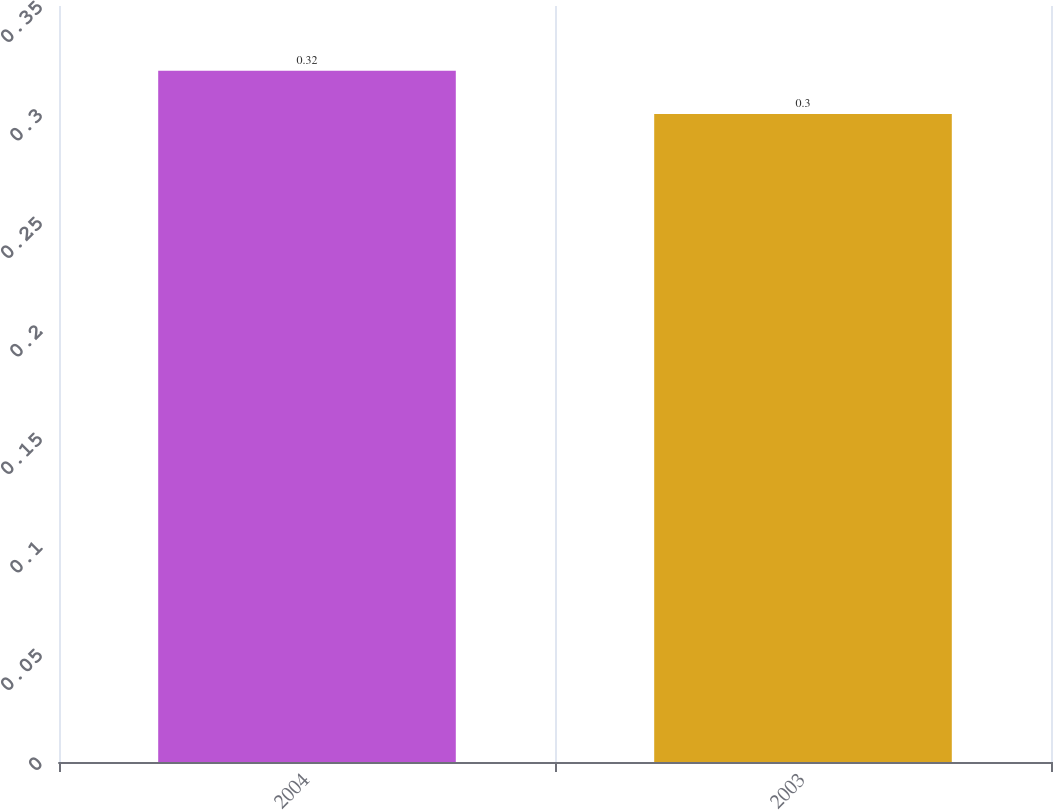Convert chart. <chart><loc_0><loc_0><loc_500><loc_500><bar_chart><fcel>2004<fcel>2003<nl><fcel>0.32<fcel>0.3<nl></chart> 